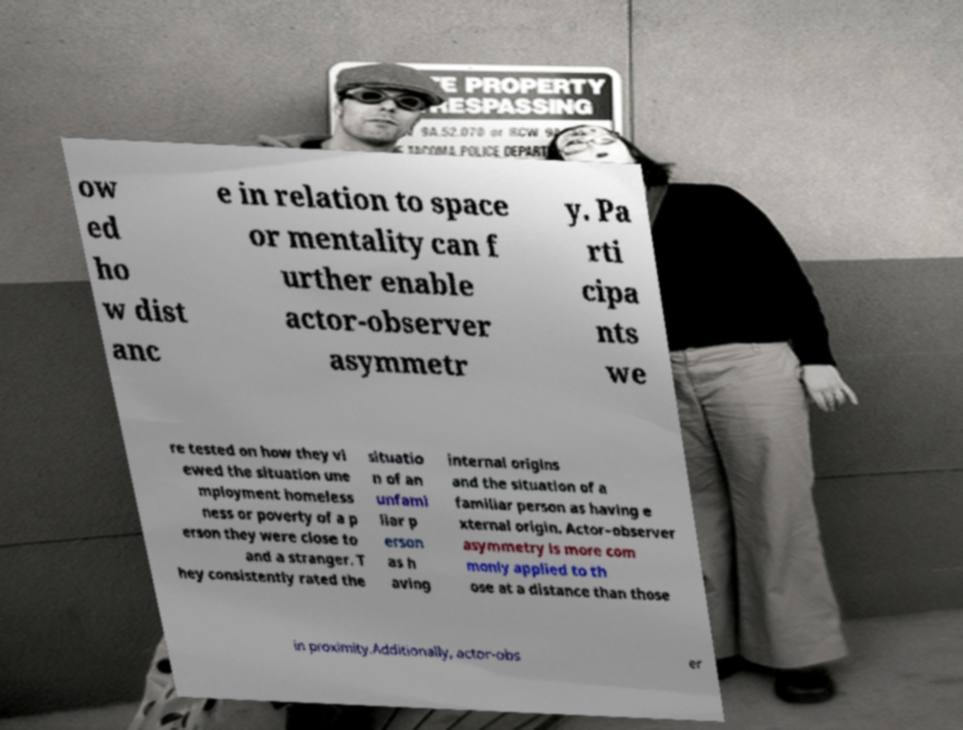Could you assist in decoding the text presented in this image and type it out clearly? ow ed ho w dist anc e in relation to space or mentality can f urther enable actor-observer asymmetr y. Pa rti cipa nts we re tested on how they vi ewed the situation une mployment homeless ness or poverty of a p erson they were close to and a stranger. T hey consistently rated the situatio n of an unfami liar p erson as h aving internal origins and the situation of a familiar person as having e xternal origin. Actor–observer asymmetry is more com monly applied to th ose at a distance than those in proximity.Additionally, actor-obs er 